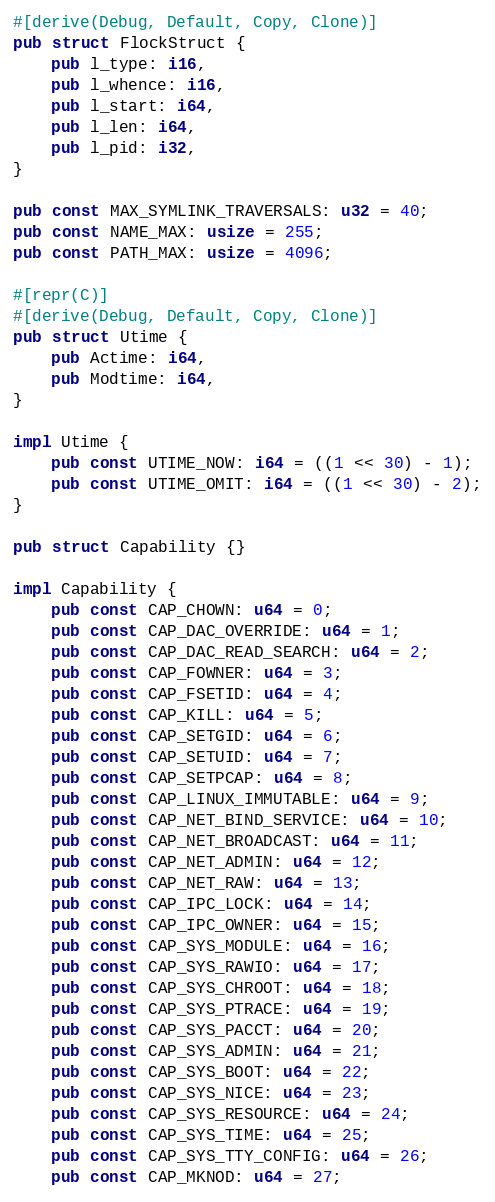Convert code to text. <code><loc_0><loc_0><loc_500><loc_500><_Rust_>#[derive(Debug, Default, Copy, Clone)]
pub struct FlockStruct {
    pub l_type: i16,
    pub l_whence: i16,
    pub l_start: i64,
    pub l_len: i64,
    pub l_pid: i32,
}

pub const MAX_SYMLINK_TRAVERSALS: u32 = 40;
pub const NAME_MAX: usize = 255;
pub const PATH_MAX: usize = 4096;

#[repr(C)]
#[derive(Debug, Default, Copy, Clone)]
pub struct Utime {
    pub Actime: i64,
    pub Modtime: i64,
}

impl Utime {
    pub const UTIME_NOW: i64 = ((1 << 30) - 1);
    pub const UTIME_OMIT: i64 = ((1 << 30) - 2);
}

pub struct Capability {}

impl Capability {
    pub const CAP_CHOWN: u64 = 0;
    pub const CAP_DAC_OVERRIDE: u64 = 1;
    pub const CAP_DAC_READ_SEARCH: u64 = 2;
    pub const CAP_FOWNER: u64 = 3;
    pub const CAP_FSETID: u64 = 4;
    pub const CAP_KILL: u64 = 5;
    pub const CAP_SETGID: u64 = 6;
    pub const CAP_SETUID: u64 = 7;
    pub const CAP_SETPCAP: u64 = 8;
    pub const CAP_LINUX_IMMUTABLE: u64 = 9;
    pub const CAP_NET_BIND_SERVICE: u64 = 10;
    pub const CAP_NET_BROADCAST: u64 = 11;
    pub const CAP_NET_ADMIN: u64 = 12;
    pub const CAP_NET_RAW: u64 = 13;
    pub const CAP_IPC_LOCK: u64 = 14;
    pub const CAP_IPC_OWNER: u64 = 15;
    pub const CAP_SYS_MODULE: u64 = 16;
    pub const CAP_SYS_RAWIO: u64 = 17;
    pub const CAP_SYS_CHROOT: u64 = 18;
    pub const CAP_SYS_PTRACE: u64 = 19;
    pub const CAP_SYS_PACCT: u64 = 20;
    pub const CAP_SYS_ADMIN: u64 = 21;
    pub const CAP_SYS_BOOT: u64 = 22;
    pub const CAP_SYS_NICE: u64 = 23;
    pub const CAP_SYS_RESOURCE: u64 = 24;
    pub const CAP_SYS_TIME: u64 = 25;
    pub const CAP_SYS_TTY_CONFIG: u64 = 26;
    pub const CAP_MKNOD: u64 = 27;</code> 